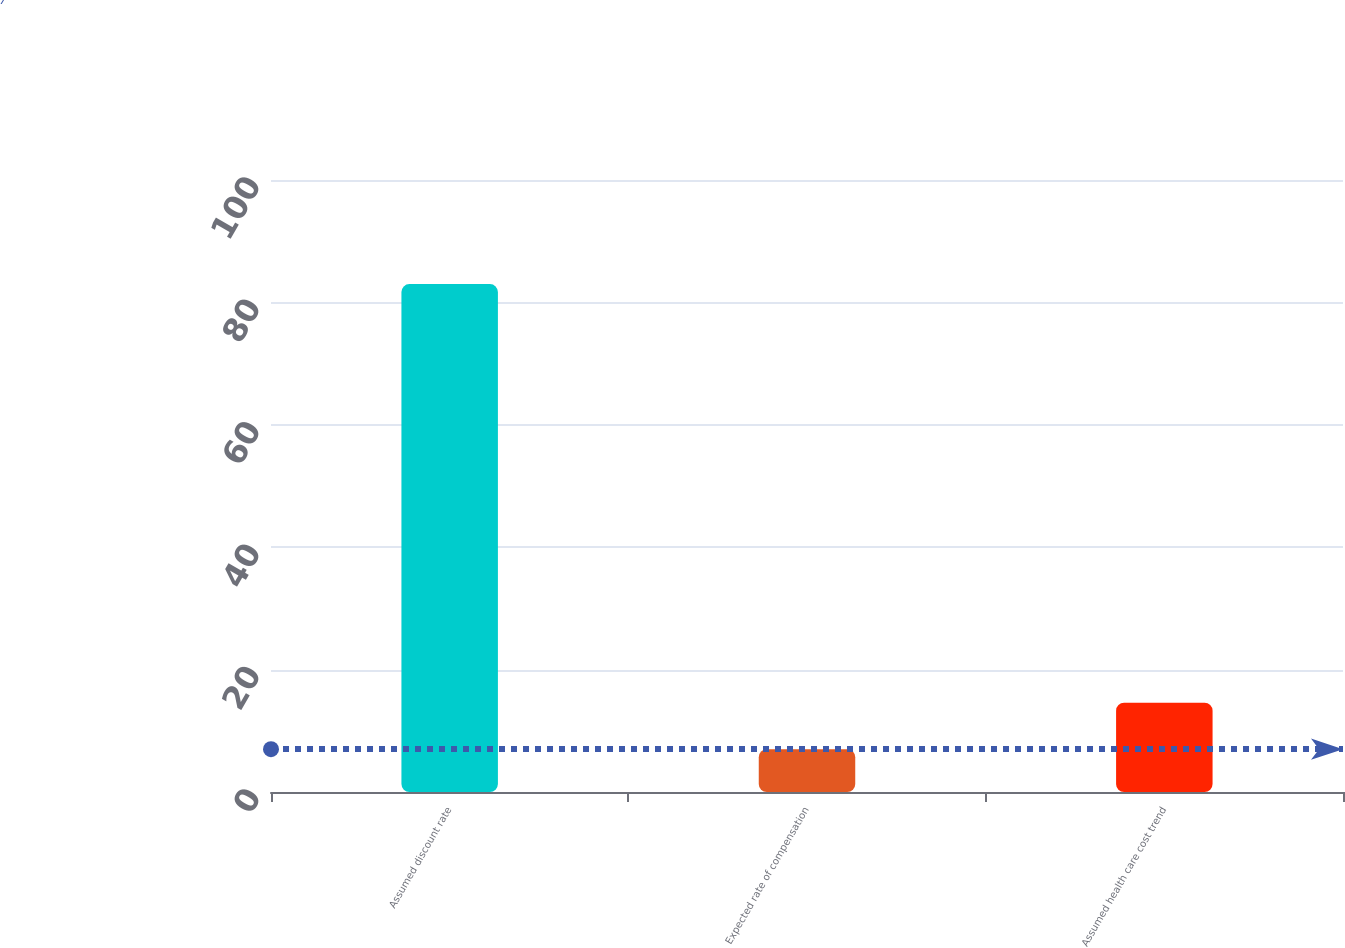<chart> <loc_0><loc_0><loc_500><loc_500><bar_chart><fcel>Assumed discount rate<fcel>Expected rate of compensation<fcel>Assumed health care cost trend<nl><fcel>83<fcel>7<fcel>14.6<nl></chart> 